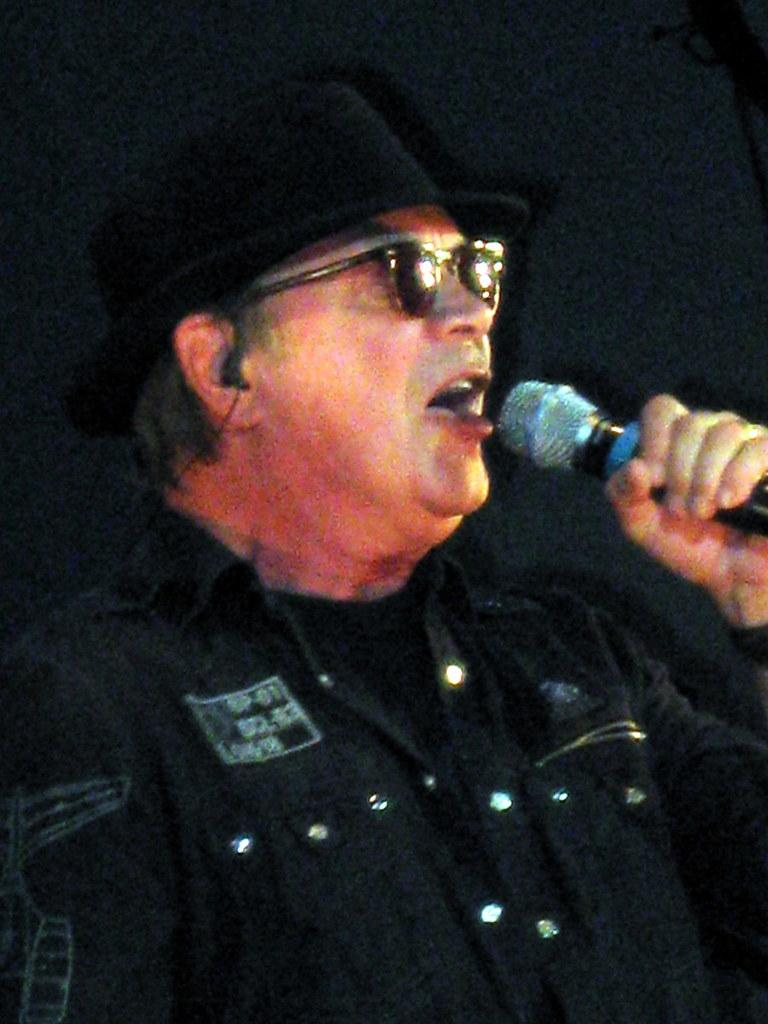What is the person in the image doing? The person in the image is singing a song. What object is the person holding while singing? The person is holding a microphone. What color is the dress the person is wearing? The person is wearing a black-colored dress. What type of eyewear is the person wearing? The person is wearing goggles. What type of headwear is the person wearing? The person is wearing a hat. How many porters are assisting the visitor in the image? There is no visitor or porter present in the image; it features a person singing with a microphone. 